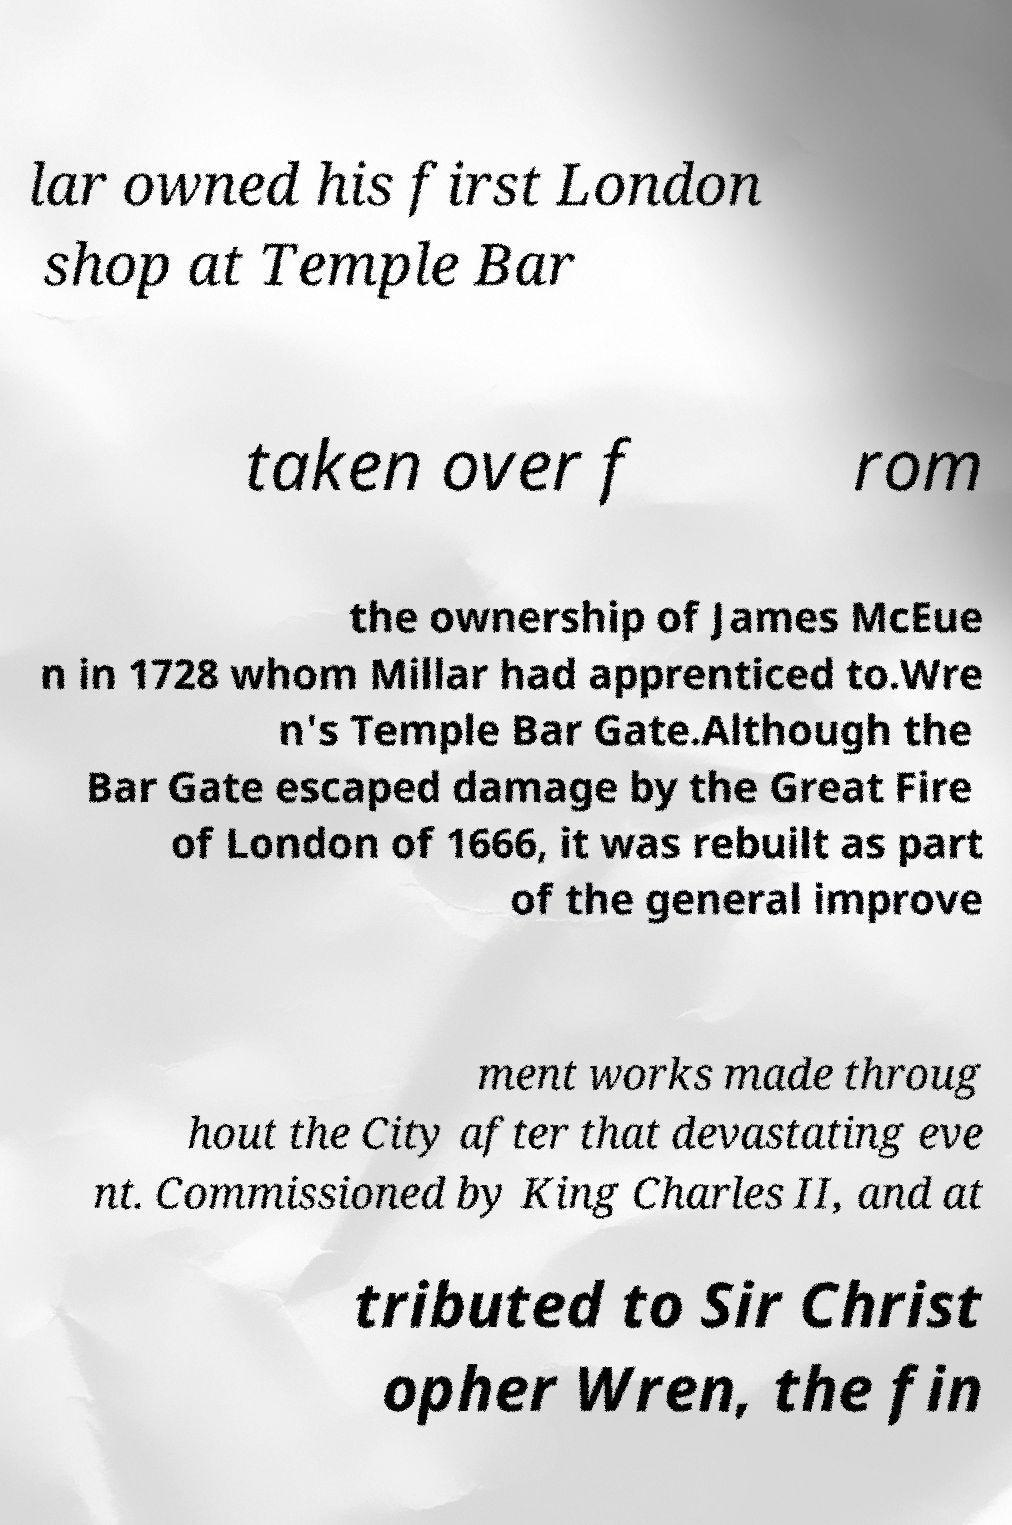Please identify and transcribe the text found in this image. lar owned his first London shop at Temple Bar taken over f rom the ownership of James McEue n in 1728 whom Millar had apprenticed to.Wre n's Temple Bar Gate.Although the Bar Gate escaped damage by the Great Fire of London of 1666, it was rebuilt as part of the general improve ment works made throug hout the City after that devastating eve nt. Commissioned by King Charles II, and at tributed to Sir Christ opher Wren, the fin 